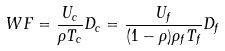<formula> <loc_0><loc_0><loc_500><loc_500>W F = \frac { U _ { c } } { \rho T _ { c } } D _ { c } = \frac { U _ { f } } { ( 1 - \rho ) \rho _ { f } T _ { f } } D _ { f }</formula> 